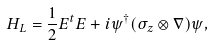<formula> <loc_0><loc_0><loc_500><loc_500>H _ { L } = \frac { 1 } { 2 } E ^ { t } E + i \psi ^ { \dagger } ( \sigma _ { z } \otimes \nabla ) \psi ,</formula> 